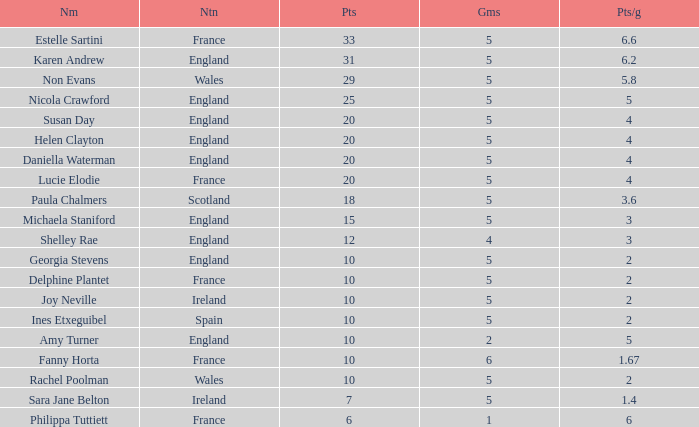Can you tell me the average Points that has a Pts/game larger than 4, and the Nation of england, and the Games smaller than 5? 10.0. 